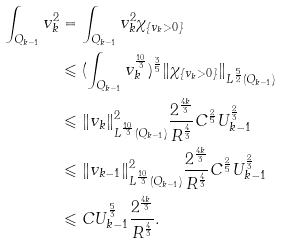<formula> <loc_0><loc_0><loc_500><loc_500>\int _ { Q _ { k - 1 } } v _ { k } ^ { 2 } & = \int _ { Q _ { k - 1 } } v _ { k } ^ { 2 } \chi _ { \{ v _ { k } > 0 \} } \\ & \leqslant ( \int _ { Q _ { k - 1 } } v _ { k } ^ { \frac { 1 0 } { 3 } } ) ^ { \frac { 3 } { 5 } } \| \chi _ { \{ v _ { k } > 0 \} } \| _ { L ^ { \frac { 5 } { 2 } } ( Q _ { k - 1 } ) } \\ & \leqslant \| v _ { k } \| _ { L ^ { \frac { 1 0 } { 3 } } ( Q _ { k - 1 } ) } ^ { 2 } \frac { 2 ^ { \frac { 4 k } { 3 } } } { R ^ { \frac { 4 } { 3 } } } C ^ { \frac { 2 } { 5 } } U _ { k - 1 } ^ { \frac { 2 } { 3 } } \\ & \leqslant \| v _ { k - 1 } \| _ { L ^ { \frac { 1 0 } { 3 } } ( Q _ { k - 1 } ) } ^ { 2 } \frac { 2 ^ { \frac { 4 k } { 3 } } } { R ^ { \frac { 4 } { 3 } } } C ^ { \frac { 2 } { 5 } } U _ { k - 1 } ^ { \frac { 2 } { 3 } } \\ & \leqslant C U _ { k - 1 } ^ { \frac { 5 } { 3 } } \frac { 2 ^ { \frac { 4 k } { 3 } } } { R ^ { \frac { 4 } { 3 } } } .</formula> 